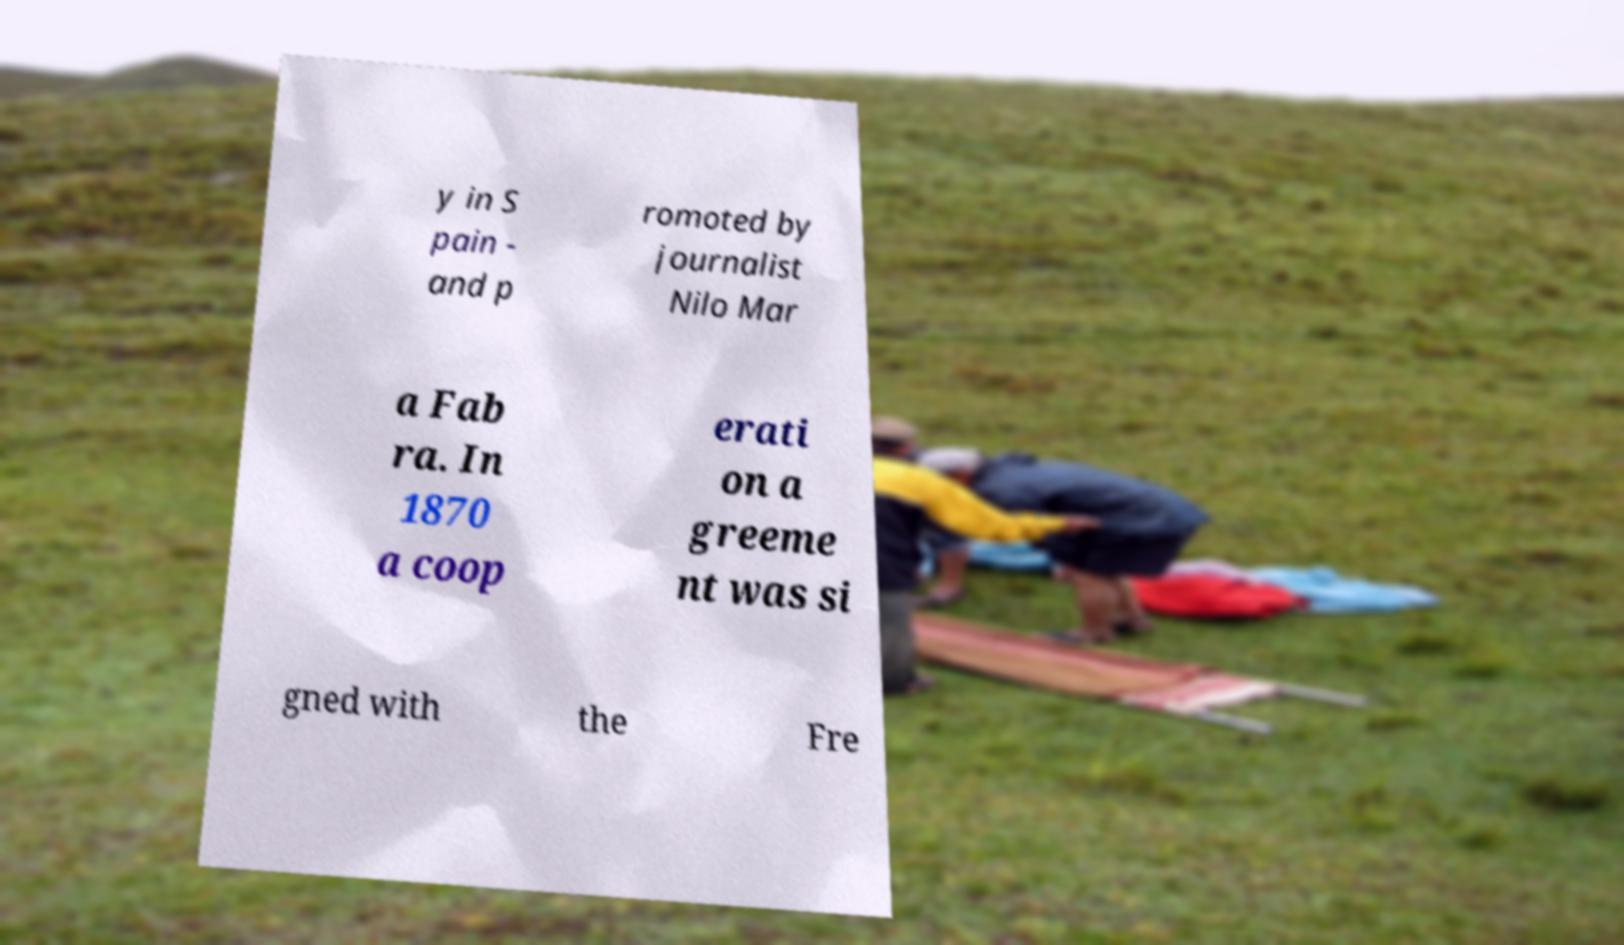For documentation purposes, I need the text within this image transcribed. Could you provide that? y in S pain - and p romoted by journalist Nilo Mar a Fab ra. In 1870 a coop erati on a greeme nt was si gned with the Fre 